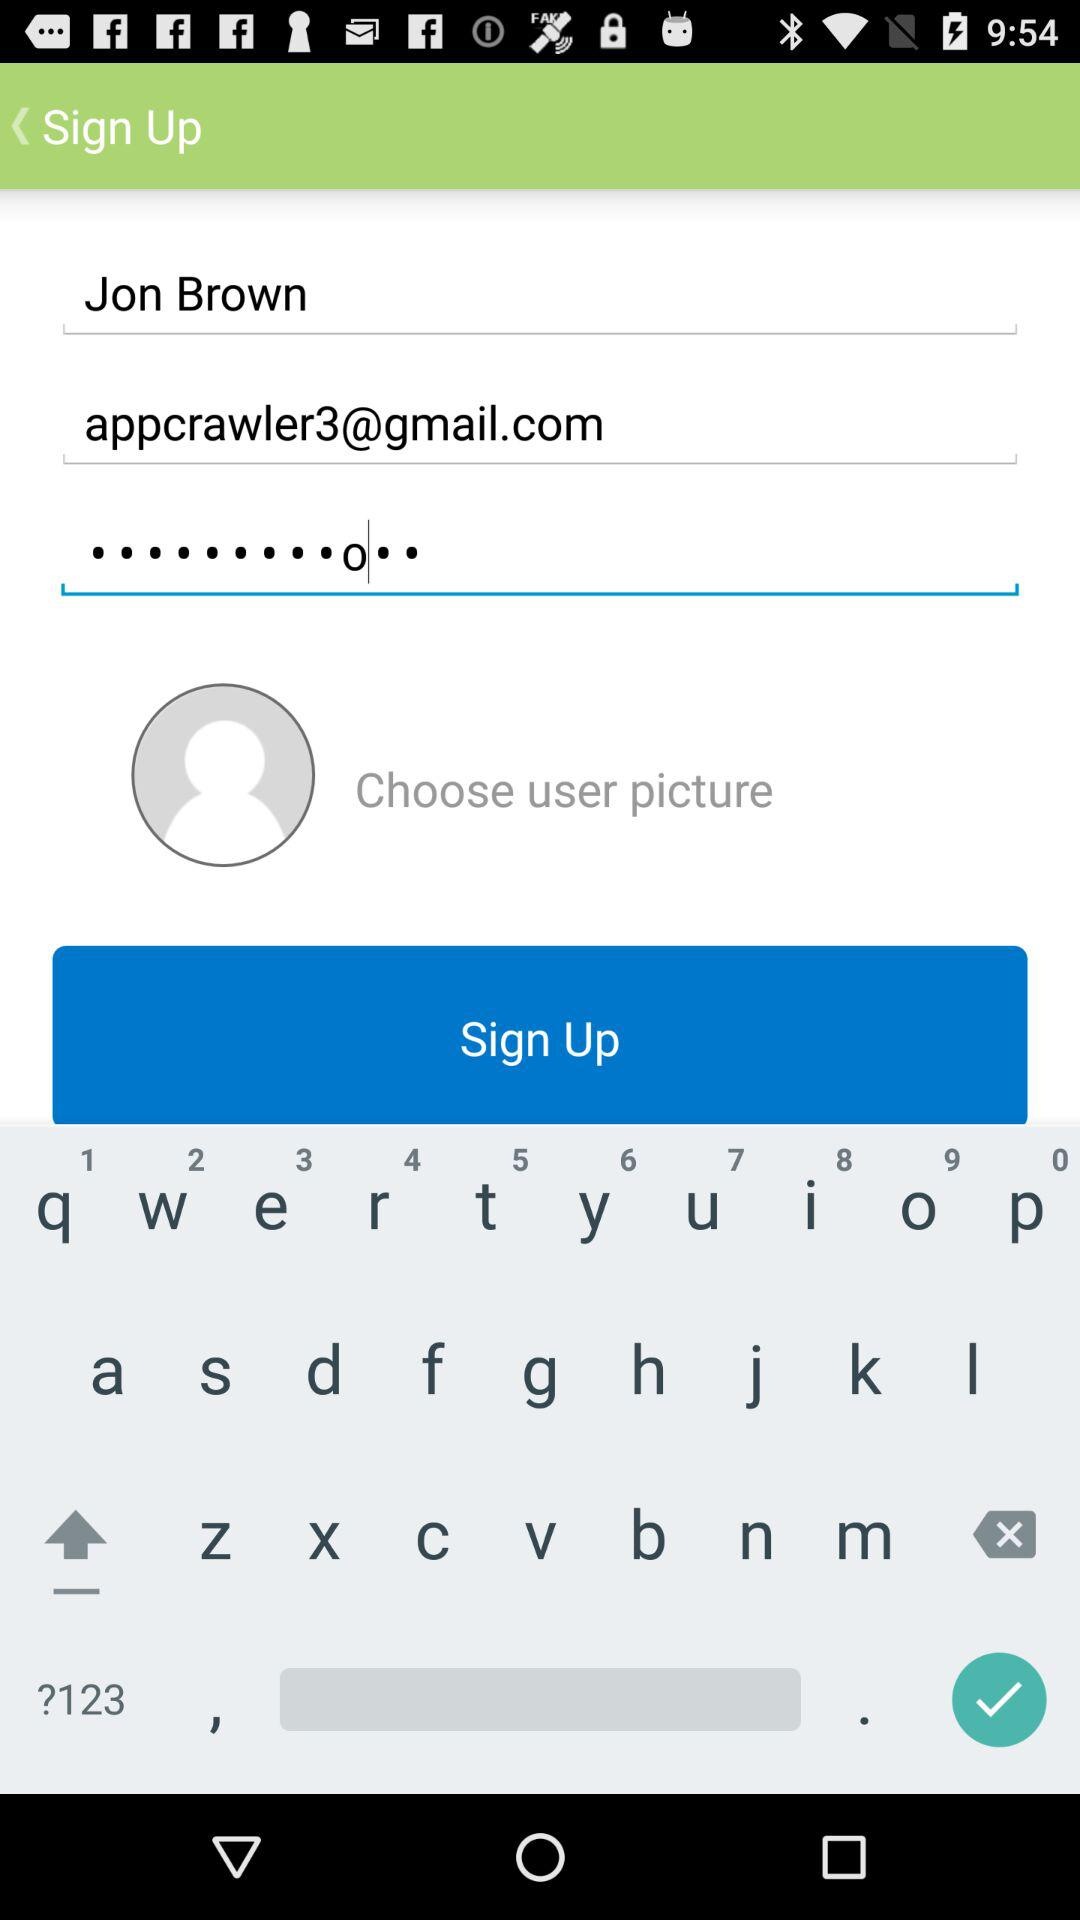How many text inputs are there for entering personal information?
Answer the question using a single word or phrase. 3 